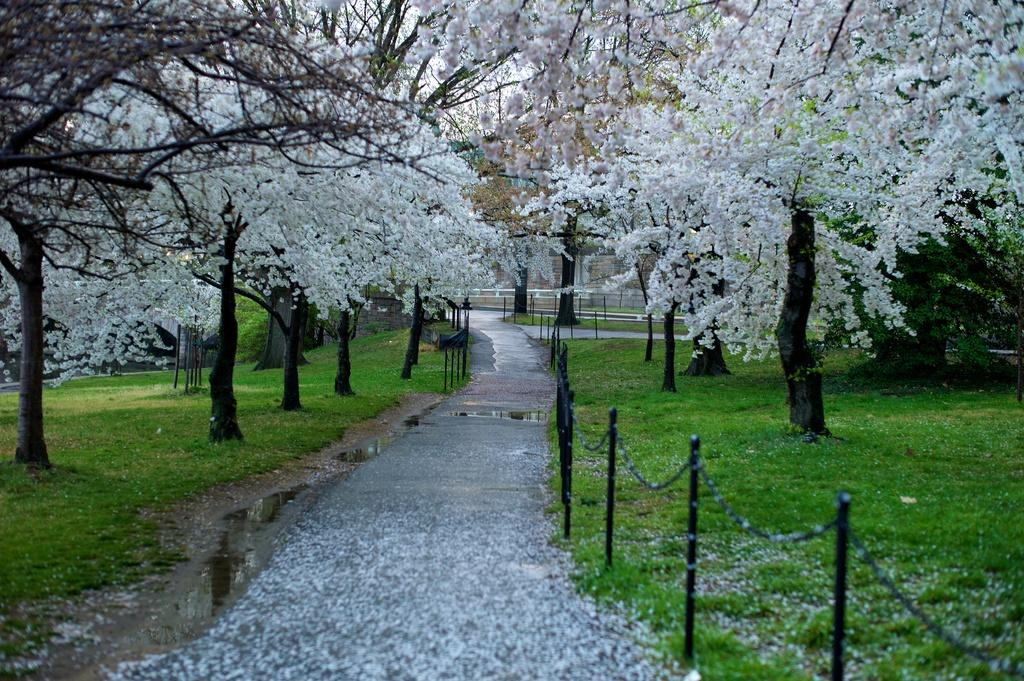What type of vegetation can be seen on the road in the image? There are flowers on the road in the image. What natural element is visible in the image? Water is visible in the image. What type of barrier is present in the image? There is a fence in the image. What type of ground cover is present in the image? There is grass in the image. What type of tall plants are present in the image? There are trees in the image. What type of structure is present in the image? There is a building in the image. What part of the natural environment is visible in the image? The sky is visible in the image. What type of location might the image depict? The image may have been taken in a park. How many mittens can be seen hanging on the fence in the image? There are no mittens present in the image. What type of insect is crawling on the building in the image? There are no insects present in the image. 